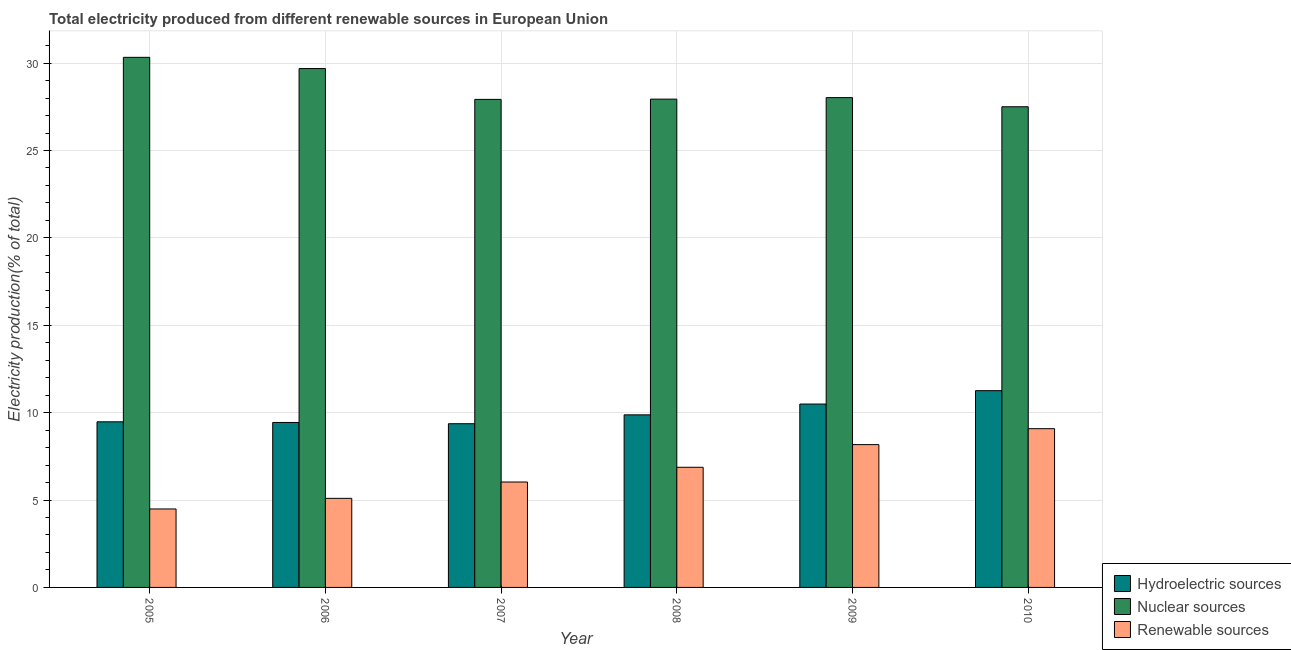Are the number of bars per tick equal to the number of legend labels?
Keep it short and to the point. Yes. Are the number of bars on each tick of the X-axis equal?
Make the answer very short. Yes. How many bars are there on the 6th tick from the left?
Make the answer very short. 3. How many bars are there on the 5th tick from the right?
Your answer should be very brief. 3. What is the label of the 2nd group of bars from the left?
Your answer should be compact. 2006. In how many cases, is the number of bars for a given year not equal to the number of legend labels?
Give a very brief answer. 0. What is the percentage of electricity produced by nuclear sources in 2005?
Provide a succinct answer. 30.33. Across all years, what is the maximum percentage of electricity produced by hydroelectric sources?
Your answer should be very brief. 11.26. Across all years, what is the minimum percentage of electricity produced by nuclear sources?
Provide a short and direct response. 27.5. In which year was the percentage of electricity produced by hydroelectric sources maximum?
Make the answer very short. 2010. In which year was the percentage of electricity produced by nuclear sources minimum?
Ensure brevity in your answer.  2010. What is the total percentage of electricity produced by nuclear sources in the graph?
Your answer should be very brief. 171.41. What is the difference between the percentage of electricity produced by hydroelectric sources in 2007 and that in 2008?
Provide a succinct answer. -0.51. What is the difference between the percentage of electricity produced by renewable sources in 2007 and the percentage of electricity produced by nuclear sources in 2006?
Make the answer very short. 0.94. What is the average percentage of electricity produced by hydroelectric sources per year?
Your answer should be compact. 9.98. In the year 2008, what is the difference between the percentage of electricity produced by renewable sources and percentage of electricity produced by nuclear sources?
Your answer should be very brief. 0. What is the ratio of the percentage of electricity produced by hydroelectric sources in 2005 to that in 2006?
Offer a very short reply. 1. Is the percentage of electricity produced by renewable sources in 2006 less than that in 2009?
Offer a very short reply. Yes. What is the difference between the highest and the second highest percentage of electricity produced by renewable sources?
Ensure brevity in your answer.  0.91. What is the difference between the highest and the lowest percentage of electricity produced by renewable sources?
Offer a terse response. 4.59. In how many years, is the percentage of electricity produced by renewable sources greater than the average percentage of electricity produced by renewable sources taken over all years?
Provide a succinct answer. 3. Is the sum of the percentage of electricity produced by renewable sources in 2005 and 2008 greater than the maximum percentage of electricity produced by hydroelectric sources across all years?
Ensure brevity in your answer.  Yes. What does the 2nd bar from the left in 2007 represents?
Provide a short and direct response. Nuclear sources. What does the 3rd bar from the right in 2010 represents?
Your answer should be compact. Hydroelectric sources. Is it the case that in every year, the sum of the percentage of electricity produced by hydroelectric sources and percentage of electricity produced by nuclear sources is greater than the percentage of electricity produced by renewable sources?
Your answer should be compact. Yes. How many bars are there?
Provide a short and direct response. 18. How many years are there in the graph?
Ensure brevity in your answer.  6. Where does the legend appear in the graph?
Offer a terse response. Bottom right. How are the legend labels stacked?
Your response must be concise. Vertical. What is the title of the graph?
Offer a terse response. Total electricity produced from different renewable sources in European Union. What is the Electricity production(% of total) of Hydroelectric sources in 2005?
Keep it short and to the point. 9.48. What is the Electricity production(% of total) of Nuclear sources in 2005?
Give a very brief answer. 30.33. What is the Electricity production(% of total) in Renewable sources in 2005?
Make the answer very short. 4.49. What is the Electricity production(% of total) in Hydroelectric sources in 2006?
Provide a succinct answer. 9.44. What is the Electricity production(% of total) of Nuclear sources in 2006?
Make the answer very short. 29.69. What is the Electricity production(% of total) in Renewable sources in 2006?
Offer a very short reply. 5.1. What is the Electricity production(% of total) in Hydroelectric sources in 2007?
Your answer should be very brief. 9.37. What is the Electricity production(% of total) of Nuclear sources in 2007?
Provide a succinct answer. 27.93. What is the Electricity production(% of total) of Renewable sources in 2007?
Provide a succinct answer. 6.03. What is the Electricity production(% of total) of Hydroelectric sources in 2008?
Provide a succinct answer. 9.87. What is the Electricity production(% of total) of Nuclear sources in 2008?
Your answer should be very brief. 27.94. What is the Electricity production(% of total) of Renewable sources in 2008?
Your answer should be very brief. 6.87. What is the Electricity production(% of total) in Hydroelectric sources in 2009?
Your answer should be compact. 10.49. What is the Electricity production(% of total) in Nuclear sources in 2009?
Provide a short and direct response. 28.03. What is the Electricity production(% of total) in Renewable sources in 2009?
Ensure brevity in your answer.  8.17. What is the Electricity production(% of total) in Hydroelectric sources in 2010?
Provide a succinct answer. 11.26. What is the Electricity production(% of total) of Nuclear sources in 2010?
Ensure brevity in your answer.  27.5. What is the Electricity production(% of total) in Renewable sources in 2010?
Your answer should be very brief. 9.08. Across all years, what is the maximum Electricity production(% of total) in Hydroelectric sources?
Keep it short and to the point. 11.26. Across all years, what is the maximum Electricity production(% of total) in Nuclear sources?
Keep it short and to the point. 30.33. Across all years, what is the maximum Electricity production(% of total) in Renewable sources?
Provide a short and direct response. 9.08. Across all years, what is the minimum Electricity production(% of total) of Hydroelectric sources?
Keep it short and to the point. 9.37. Across all years, what is the minimum Electricity production(% of total) of Nuclear sources?
Make the answer very short. 27.5. Across all years, what is the minimum Electricity production(% of total) of Renewable sources?
Provide a succinct answer. 4.49. What is the total Electricity production(% of total) in Hydroelectric sources in the graph?
Ensure brevity in your answer.  59.91. What is the total Electricity production(% of total) of Nuclear sources in the graph?
Give a very brief answer. 171.41. What is the total Electricity production(% of total) of Renewable sources in the graph?
Your answer should be compact. 39.75. What is the difference between the Electricity production(% of total) of Hydroelectric sources in 2005 and that in 2006?
Your answer should be compact. 0.04. What is the difference between the Electricity production(% of total) in Nuclear sources in 2005 and that in 2006?
Your response must be concise. 0.64. What is the difference between the Electricity production(% of total) of Renewable sources in 2005 and that in 2006?
Keep it short and to the point. -0.61. What is the difference between the Electricity production(% of total) of Hydroelectric sources in 2005 and that in 2007?
Your response must be concise. 0.11. What is the difference between the Electricity production(% of total) in Nuclear sources in 2005 and that in 2007?
Provide a succinct answer. 2.41. What is the difference between the Electricity production(% of total) in Renewable sources in 2005 and that in 2007?
Your response must be concise. -1.54. What is the difference between the Electricity production(% of total) in Hydroelectric sources in 2005 and that in 2008?
Offer a very short reply. -0.4. What is the difference between the Electricity production(% of total) of Nuclear sources in 2005 and that in 2008?
Your answer should be very brief. 2.39. What is the difference between the Electricity production(% of total) of Renewable sources in 2005 and that in 2008?
Offer a very short reply. -2.39. What is the difference between the Electricity production(% of total) of Hydroelectric sources in 2005 and that in 2009?
Your answer should be compact. -1.02. What is the difference between the Electricity production(% of total) of Nuclear sources in 2005 and that in 2009?
Provide a succinct answer. 2.31. What is the difference between the Electricity production(% of total) of Renewable sources in 2005 and that in 2009?
Your response must be concise. -3.68. What is the difference between the Electricity production(% of total) of Hydroelectric sources in 2005 and that in 2010?
Offer a terse response. -1.78. What is the difference between the Electricity production(% of total) of Nuclear sources in 2005 and that in 2010?
Offer a terse response. 2.83. What is the difference between the Electricity production(% of total) of Renewable sources in 2005 and that in 2010?
Provide a succinct answer. -4.59. What is the difference between the Electricity production(% of total) in Hydroelectric sources in 2006 and that in 2007?
Provide a short and direct response. 0.07. What is the difference between the Electricity production(% of total) in Nuclear sources in 2006 and that in 2007?
Offer a terse response. 1.76. What is the difference between the Electricity production(% of total) in Renewable sources in 2006 and that in 2007?
Keep it short and to the point. -0.94. What is the difference between the Electricity production(% of total) in Hydroelectric sources in 2006 and that in 2008?
Your answer should be very brief. -0.44. What is the difference between the Electricity production(% of total) in Nuclear sources in 2006 and that in 2008?
Provide a succinct answer. 1.75. What is the difference between the Electricity production(% of total) in Renewable sources in 2006 and that in 2008?
Give a very brief answer. -1.78. What is the difference between the Electricity production(% of total) of Hydroelectric sources in 2006 and that in 2009?
Keep it short and to the point. -1.05. What is the difference between the Electricity production(% of total) of Nuclear sources in 2006 and that in 2009?
Your answer should be very brief. 1.66. What is the difference between the Electricity production(% of total) in Renewable sources in 2006 and that in 2009?
Your answer should be very brief. -3.07. What is the difference between the Electricity production(% of total) in Hydroelectric sources in 2006 and that in 2010?
Provide a short and direct response. -1.82. What is the difference between the Electricity production(% of total) in Nuclear sources in 2006 and that in 2010?
Offer a terse response. 2.19. What is the difference between the Electricity production(% of total) in Renewable sources in 2006 and that in 2010?
Provide a short and direct response. -3.99. What is the difference between the Electricity production(% of total) in Hydroelectric sources in 2007 and that in 2008?
Offer a terse response. -0.51. What is the difference between the Electricity production(% of total) in Nuclear sources in 2007 and that in 2008?
Keep it short and to the point. -0.01. What is the difference between the Electricity production(% of total) in Renewable sources in 2007 and that in 2008?
Make the answer very short. -0.84. What is the difference between the Electricity production(% of total) in Hydroelectric sources in 2007 and that in 2009?
Provide a short and direct response. -1.13. What is the difference between the Electricity production(% of total) of Nuclear sources in 2007 and that in 2009?
Your answer should be compact. -0.1. What is the difference between the Electricity production(% of total) of Renewable sources in 2007 and that in 2009?
Offer a terse response. -2.14. What is the difference between the Electricity production(% of total) in Hydroelectric sources in 2007 and that in 2010?
Your answer should be compact. -1.89. What is the difference between the Electricity production(% of total) of Nuclear sources in 2007 and that in 2010?
Your answer should be very brief. 0.42. What is the difference between the Electricity production(% of total) of Renewable sources in 2007 and that in 2010?
Keep it short and to the point. -3.05. What is the difference between the Electricity production(% of total) of Hydroelectric sources in 2008 and that in 2009?
Offer a very short reply. -0.62. What is the difference between the Electricity production(% of total) of Nuclear sources in 2008 and that in 2009?
Your answer should be very brief. -0.09. What is the difference between the Electricity production(% of total) in Renewable sources in 2008 and that in 2009?
Offer a terse response. -1.3. What is the difference between the Electricity production(% of total) of Hydroelectric sources in 2008 and that in 2010?
Make the answer very short. -1.38. What is the difference between the Electricity production(% of total) in Nuclear sources in 2008 and that in 2010?
Give a very brief answer. 0.44. What is the difference between the Electricity production(% of total) of Renewable sources in 2008 and that in 2010?
Keep it short and to the point. -2.21. What is the difference between the Electricity production(% of total) in Hydroelectric sources in 2009 and that in 2010?
Keep it short and to the point. -0.77. What is the difference between the Electricity production(% of total) in Nuclear sources in 2009 and that in 2010?
Your response must be concise. 0.52. What is the difference between the Electricity production(% of total) in Renewable sources in 2009 and that in 2010?
Give a very brief answer. -0.91. What is the difference between the Electricity production(% of total) of Hydroelectric sources in 2005 and the Electricity production(% of total) of Nuclear sources in 2006?
Your answer should be very brief. -20.21. What is the difference between the Electricity production(% of total) in Hydroelectric sources in 2005 and the Electricity production(% of total) in Renewable sources in 2006?
Ensure brevity in your answer.  4.38. What is the difference between the Electricity production(% of total) of Nuclear sources in 2005 and the Electricity production(% of total) of Renewable sources in 2006?
Your answer should be compact. 25.23. What is the difference between the Electricity production(% of total) of Hydroelectric sources in 2005 and the Electricity production(% of total) of Nuclear sources in 2007?
Ensure brevity in your answer.  -18.45. What is the difference between the Electricity production(% of total) in Hydroelectric sources in 2005 and the Electricity production(% of total) in Renewable sources in 2007?
Your answer should be compact. 3.44. What is the difference between the Electricity production(% of total) of Nuclear sources in 2005 and the Electricity production(% of total) of Renewable sources in 2007?
Your answer should be very brief. 24.3. What is the difference between the Electricity production(% of total) in Hydroelectric sources in 2005 and the Electricity production(% of total) in Nuclear sources in 2008?
Make the answer very short. -18.46. What is the difference between the Electricity production(% of total) of Hydroelectric sources in 2005 and the Electricity production(% of total) of Renewable sources in 2008?
Provide a short and direct response. 2.6. What is the difference between the Electricity production(% of total) of Nuclear sources in 2005 and the Electricity production(% of total) of Renewable sources in 2008?
Your answer should be very brief. 23.46. What is the difference between the Electricity production(% of total) of Hydroelectric sources in 2005 and the Electricity production(% of total) of Nuclear sources in 2009?
Give a very brief answer. -18.55. What is the difference between the Electricity production(% of total) in Hydroelectric sources in 2005 and the Electricity production(% of total) in Renewable sources in 2009?
Make the answer very short. 1.31. What is the difference between the Electricity production(% of total) in Nuclear sources in 2005 and the Electricity production(% of total) in Renewable sources in 2009?
Your answer should be compact. 22.16. What is the difference between the Electricity production(% of total) in Hydroelectric sources in 2005 and the Electricity production(% of total) in Nuclear sources in 2010?
Your answer should be compact. -18.03. What is the difference between the Electricity production(% of total) in Hydroelectric sources in 2005 and the Electricity production(% of total) in Renewable sources in 2010?
Your answer should be compact. 0.39. What is the difference between the Electricity production(% of total) of Nuclear sources in 2005 and the Electricity production(% of total) of Renewable sources in 2010?
Ensure brevity in your answer.  21.25. What is the difference between the Electricity production(% of total) of Hydroelectric sources in 2006 and the Electricity production(% of total) of Nuclear sources in 2007?
Provide a short and direct response. -18.49. What is the difference between the Electricity production(% of total) of Hydroelectric sources in 2006 and the Electricity production(% of total) of Renewable sources in 2007?
Provide a short and direct response. 3.41. What is the difference between the Electricity production(% of total) of Nuclear sources in 2006 and the Electricity production(% of total) of Renewable sources in 2007?
Keep it short and to the point. 23.66. What is the difference between the Electricity production(% of total) of Hydroelectric sources in 2006 and the Electricity production(% of total) of Nuclear sources in 2008?
Offer a terse response. -18.5. What is the difference between the Electricity production(% of total) of Hydroelectric sources in 2006 and the Electricity production(% of total) of Renewable sources in 2008?
Offer a terse response. 2.56. What is the difference between the Electricity production(% of total) of Nuclear sources in 2006 and the Electricity production(% of total) of Renewable sources in 2008?
Your response must be concise. 22.81. What is the difference between the Electricity production(% of total) in Hydroelectric sources in 2006 and the Electricity production(% of total) in Nuclear sources in 2009?
Provide a short and direct response. -18.59. What is the difference between the Electricity production(% of total) in Hydroelectric sources in 2006 and the Electricity production(% of total) in Renewable sources in 2009?
Make the answer very short. 1.27. What is the difference between the Electricity production(% of total) in Nuclear sources in 2006 and the Electricity production(% of total) in Renewable sources in 2009?
Your answer should be very brief. 21.52. What is the difference between the Electricity production(% of total) of Hydroelectric sources in 2006 and the Electricity production(% of total) of Nuclear sources in 2010?
Make the answer very short. -18.06. What is the difference between the Electricity production(% of total) of Hydroelectric sources in 2006 and the Electricity production(% of total) of Renewable sources in 2010?
Ensure brevity in your answer.  0.36. What is the difference between the Electricity production(% of total) in Nuclear sources in 2006 and the Electricity production(% of total) in Renewable sources in 2010?
Offer a very short reply. 20.61. What is the difference between the Electricity production(% of total) of Hydroelectric sources in 2007 and the Electricity production(% of total) of Nuclear sources in 2008?
Make the answer very short. -18.57. What is the difference between the Electricity production(% of total) in Hydroelectric sources in 2007 and the Electricity production(% of total) in Renewable sources in 2008?
Your response must be concise. 2.49. What is the difference between the Electricity production(% of total) of Nuclear sources in 2007 and the Electricity production(% of total) of Renewable sources in 2008?
Your answer should be compact. 21.05. What is the difference between the Electricity production(% of total) in Hydroelectric sources in 2007 and the Electricity production(% of total) in Nuclear sources in 2009?
Offer a very short reply. -18.66. What is the difference between the Electricity production(% of total) of Hydroelectric sources in 2007 and the Electricity production(% of total) of Renewable sources in 2009?
Your response must be concise. 1.2. What is the difference between the Electricity production(% of total) in Nuclear sources in 2007 and the Electricity production(% of total) in Renewable sources in 2009?
Give a very brief answer. 19.75. What is the difference between the Electricity production(% of total) in Hydroelectric sources in 2007 and the Electricity production(% of total) in Nuclear sources in 2010?
Offer a terse response. -18.14. What is the difference between the Electricity production(% of total) of Hydroelectric sources in 2007 and the Electricity production(% of total) of Renewable sources in 2010?
Your answer should be compact. 0.28. What is the difference between the Electricity production(% of total) of Nuclear sources in 2007 and the Electricity production(% of total) of Renewable sources in 2010?
Ensure brevity in your answer.  18.84. What is the difference between the Electricity production(% of total) of Hydroelectric sources in 2008 and the Electricity production(% of total) of Nuclear sources in 2009?
Give a very brief answer. -18.15. What is the difference between the Electricity production(% of total) in Hydroelectric sources in 2008 and the Electricity production(% of total) in Renewable sources in 2009?
Provide a succinct answer. 1.7. What is the difference between the Electricity production(% of total) of Nuclear sources in 2008 and the Electricity production(% of total) of Renewable sources in 2009?
Your answer should be very brief. 19.77. What is the difference between the Electricity production(% of total) of Hydroelectric sources in 2008 and the Electricity production(% of total) of Nuclear sources in 2010?
Offer a very short reply. -17.63. What is the difference between the Electricity production(% of total) of Hydroelectric sources in 2008 and the Electricity production(% of total) of Renewable sources in 2010?
Ensure brevity in your answer.  0.79. What is the difference between the Electricity production(% of total) of Nuclear sources in 2008 and the Electricity production(% of total) of Renewable sources in 2010?
Your answer should be very brief. 18.86. What is the difference between the Electricity production(% of total) of Hydroelectric sources in 2009 and the Electricity production(% of total) of Nuclear sources in 2010?
Make the answer very short. -17.01. What is the difference between the Electricity production(% of total) in Hydroelectric sources in 2009 and the Electricity production(% of total) in Renewable sources in 2010?
Your answer should be very brief. 1.41. What is the difference between the Electricity production(% of total) in Nuclear sources in 2009 and the Electricity production(% of total) in Renewable sources in 2010?
Your answer should be very brief. 18.94. What is the average Electricity production(% of total) in Hydroelectric sources per year?
Offer a terse response. 9.98. What is the average Electricity production(% of total) in Nuclear sources per year?
Your response must be concise. 28.57. What is the average Electricity production(% of total) in Renewable sources per year?
Keep it short and to the point. 6.62. In the year 2005, what is the difference between the Electricity production(% of total) in Hydroelectric sources and Electricity production(% of total) in Nuclear sources?
Keep it short and to the point. -20.85. In the year 2005, what is the difference between the Electricity production(% of total) in Hydroelectric sources and Electricity production(% of total) in Renewable sources?
Provide a short and direct response. 4.99. In the year 2005, what is the difference between the Electricity production(% of total) of Nuclear sources and Electricity production(% of total) of Renewable sources?
Offer a terse response. 25.84. In the year 2006, what is the difference between the Electricity production(% of total) of Hydroelectric sources and Electricity production(% of total) of Nuclear sources?
Ensure brevity in your answer.  -20.25. In the year 2006, what is the difference between the Electricity production(% of total) in Hydroelectric sources and Electricity production(% of total) in Renewable sources?
Give a very brief answer. 4.34. In the year 2006, what is the difference between the Electricity production(% of total) of Nuclear sources and Electricity production(% of total) of Renewable sources?
Your response must be concise. 24.59. In the year 2007, what is the difference between the Electricity production(% of total) of Hydroelectric sources and Electricity production(% of total) of Nuclear sources?
Provide a short and direct response. -18.56. In the year 2007, what is the difference between the Electricity production(% of total) of Hydroelectric sources and Electricity production(% of total) of Renewable sources?
Offer a terse response. 3.34. In the year 2007, what is the difference between the Electricity production(% of total) of Nuclear sources and Electricity production(% of total) of Renewable sources?
Make the answer very short. 21.89. In the year 2008, what is the difference between the Electricity production(% of total) of Hydroelectric sources and Electricity production(% of total) of Nuclear sources?
Provide a succinct answer. -18.06. In the year 2008, what is the difference between the Electricity production(% of total) of Hydroelectric sources and Electricity production(% of total) of Renewable sources?
Ensure brevity in your answer.  3. In the year 2008, what is the difference between the Electricity production(% of total) in Nuclear sources and Electricity production(% of total) in Renewable sources?
Keep it short and to the point. 21.06. In the year 2009, what is the difference between the Electricity production(% of total) of Hydroelectric sources and Electricity production(% of total) of Nuclear sources?
Provide a succinct answer. -17.53. In the year 2009, what is the difference between the Electricity production(% of total) of Hydroelectric sources and Electricity production(% of total) of Renewable sources?
Make the answer very short. 2.32. In the year 2009, what is the difference between the Electricity production(% of total) of Nuclear sources and Electricity production(% of total) of Renewable sources?
Provide a short and direct response. 19.85. In the year 2010, what is the difference between the Electricity production(% of total) in Hydroelectric sources and Electricity production(% of total) in Nuclear sources?
Offer a terse response. -16.24. In the year 2010, what is the difference between the Electricity production(% of total) in Hydroelectric sources and Electricity production(% of total) in Renewable sources?
Your response must be concise. 2.18. In the year 2010, what is the difference between the Electricity production(% of total) in Nuclear sources and Electricity production(% of total) in Renewable sources?
Your response must be concise. 18.42. What is the ratio of the Electricity production(% of total) in Hydroelectric sources in 2005 to that in 2006?
Offer a terse response. 1. What is the ratio of the Electricity production(% of total) in Nuclear sources in 2005 to that in 2006?
Offer a terse response. 1.02. What is the ratio of the Electricity production(% of total) in Renewable sources in 2005 to that in 2006?
Make the answer very short. 0.88. What is the ratio of the Electricity production(% of total) of Hydroelectric sources in 2005 to that in 2007?
Make the answer very short. 1.01. What is the ratio of the Electricity production(% of total) of Nuclear sources in 2005 to that in 2007?
Keep it short and to the point. 1.09. What is the ratio of the Electricity production(% of total) of Renewable sources in 2005 to that in 2007?
Offer a terse response. 0.74. What is the ratio of the Electricity production(% of total) in Hydroelectric sources in 2005 to that in 2008?
Offer a very short reply. 0.96. What is the ratio of the Electricity production(% of total) of Nuclear sources in 2005 to that in 2008?
Keep it short and to the point. 1.09. What is the ratio of the Electricity production(% of total) of Renewable sources in 2005 to that in 2008?
Provide a succinct answer. 0.65. What is the ratio of the Electricity production(% of total) of Hydroelectric sources in 2005 to that in 2009?
Provide a succinct answer. 0.9. What is the ratio of the Electricity production(% of total) of Nuclear sources in 2005 to that in 2009?
Your answer should be very brief. 1.08. What is the ratio of the Electricity production(% of total) in Renewable sources in 2005 to that in 2009?
Your response must be concise. 0.55. What is the ratio of the Electricity production(% of total) of Hydroelectric sources in 2005 to that in 2010?
Provide a short and direct response. 0.84. What is the ratio of the Electricity production(% of total) in Nuclear sources in 2005 to that in 2010?
Your answer should be very brief. 1.1. What is the ratio of the Electricity production(% of total) in Renewable sources in 2005 to that in 2010?
Offer a terse response. 0.49. What is the ratio of the Electricity production(% of total) in Hydroelectric sources in 2006 to that in 2007?
Ensure brevity in your answer.  1.01. What is the ratio of the Electricity production(% of total) in Nuclear sources in 2006 to that in 2007?
Give a very brief answer. 1.06. What is the ratio of the Electricity production(% of total) in Renewable sources in 2006 to that in 2007?
Your answer should be very brief. 0.84. What is the ratio of the Electricity production(% of total) of Hydroelectric sources in 2006 to that in 2008?
Your answer should be very brief. 0.96. What is the ratio of the Electricity production(% of total) in Nuclear sources in 2006 to that in 2008?
Your response must be concise. 1.06. What is the ratio of the Electricity production(% of total) of Renewable sources in 2006 to that in 2008?
Offer a very short reply. 0.74. What is the ratio of the Electricity production(% of total) of Hydroelectric sources in 2006 to that in 2009?
Your answer should be compact. 0.9. What is the ratio of the Electricity production(% of total) in Nuclear sources in 2006 to that in 2009?
Offer a terse response. 1.06. What is the ratio of the Electricity production(% of total) in Renewable sources in 2006 to that in 2009?
Your answer should be compact. 0.62. What is the ratio of the Electricity production(% of total) in Hydroelectric sources in 2006 to that in 2010?
Provide a succinct answer. 0.84. What is the ratio of the Electricity production(% of total) of Nuclear sources in 2006 to that in 2010?
Your answer should be compact. 1.08. What is the ratio of the Electricity production(% of total) of Renewable sources in 2006 to that in 2010?
Ensure brevity in your answer.  0.56. What is the ratio of the Electricity production(% of total) in Hydroelectric sources in 2007 to that in 2008?
Offer a terse response. 0.95. What is the ratio of the Electricity production(% of total) of Renewable sources in 2007 to that in 2008?
Give a very brief answer. 0.88. What is the ratio of the Electricity production(% of total) in Hydroelectric sources in 2007 to that in 2009?
Ensure brevity in your answer.  0.89. What is the ratio of the Electricity production(% of total) of Nuclear sources in 2007 to that in 2009?
Provide a short and direct response. 1. What is the ratio of the Electricity production(% of total) in Renewable sources in 2007 to that in 2009?
Offer a very short reply. 0.74. What is the ratio of the Electricity production(% of total) in Hydroelectric sources in 2007 to that in 2010?
Provide a short and direct response. 0.83. What is the ratio of the Electricity production(% of total) in Nuclear sources in 2007 to that in 2010?
Your answer should be very brief. 1.02. What is the ratio of the Electricity production(% of total) of Renewable sources in 2007 to that in 2010?
Ensure brevity in your answer.  0.66. What is the ratio of the Electricity production(% of total) of Hydroelectric sources in 2008 to that in 2009?
Give a very brief answer. 0.94. What is the ratio of the Electricity production(% of total) of Renewable sources in 2008 to that in 2009?
Provide a short and direct response. 0.84. What is the ratio of the Electricity production(% of total) of Hydroelectric sources in 2008 to that in 2010?
Provide a succinct answer. 0.88. What is the ratio of the Electricity production(% of total) of Nuclear sources in 2008 to that in 2010?
Make the answer very short. 1.02. What is the ratio of the Electricity production(% of total) of Renewable sources in 2008 to that in 2010?
Offer a terse response. 0.76. What is the ratio of the Electricity production(% of total) of Hydroelectric sources in 2009 to that in 2010?
Ensure brevity in your answer.  0.93. What is the ratio of the Electricity production(% of total) of Nuclear sources in 2009 to that in 2010?
Your answer should be compact. 1.02. What is the ratio of the Electricity production(% of total) of Renewable sources in 2009 to that in 2010?
Your response must be concise. 0.9. What is the difference between the highest and the second highest Electricity production(% of total) in Hydroelectric sources?
Offer a very short reply. 0.77. What is the difference between the highest and the second highest Electricity production(% of total) of Nuclear sources?
Offer a very short reply. 0.64. What is the difference between the highest and the second highest Electricity production(% of total) of Renewable sources?
Make the answer very short. 0.91. What is the difference between the highest and the lowest Electricity production(% of total) in Hydroelectric sources?
Provide a succinct answer. 1.89. What is the difference between the highest and the lowest Electricity production(% of total) in Nuclear sources?
Your answer should be compact. 2.83. What is the difference between the highest and the lowest Electricity production(% of total) of Renewable sources?
Your answer should be compact. 4.59. 